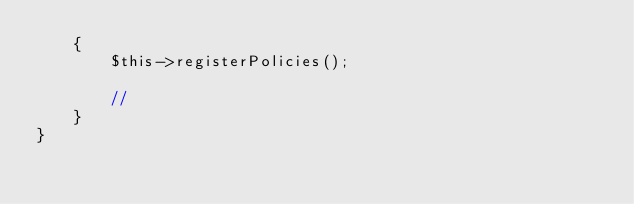Convert code to text. <code><loc_0><loc_0><loc_500><loc_500><_PHP_>    {
        $this->registerPolicies();

        //
    }
}
</code> 